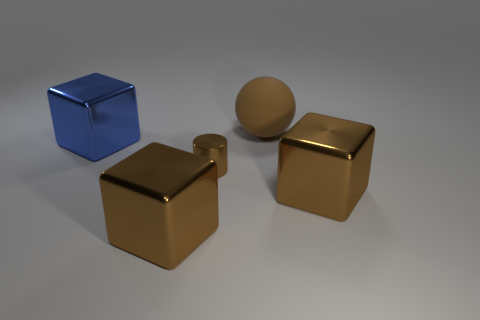The other rubber thing that is the same color as the small thing is what shape?
Provide a succinct answer. Sphere. Is the number of metal cylinders that are behind the brown matte sphere the same as the number of tiny cyan cubes?
Offer a terse response. Yes. How many objects are either shiny cylinders or large blocks in front of the brown rubber thing?
Your answer should be compact. 4. Are there any brown objects that have the same shape as the large blue thing?
Your answer should be very brief. Yes. Is the number of big brown balls behind the cylinder the same as the number of brown matte balls on the left side of the large brown rubber object?
Make the answer very short. No. Are there any other things that are the same size as the blue object?
Offer a terse response. Yes. How many brown objects are either matte objects or metal cylinders?
Ensure brevity in your answer.  2. How many brown balls are the same size as the blue metal object?
Your response must be concise. 1. There is a large shiny cube that is both left of the brown ball and in front of the blue object; what color is it?
Ensure brevity in your answer.  Brown. Are there more big objects that are in front of the tiny metal thing than brown metallic things?
Offer a very short reply. No. 